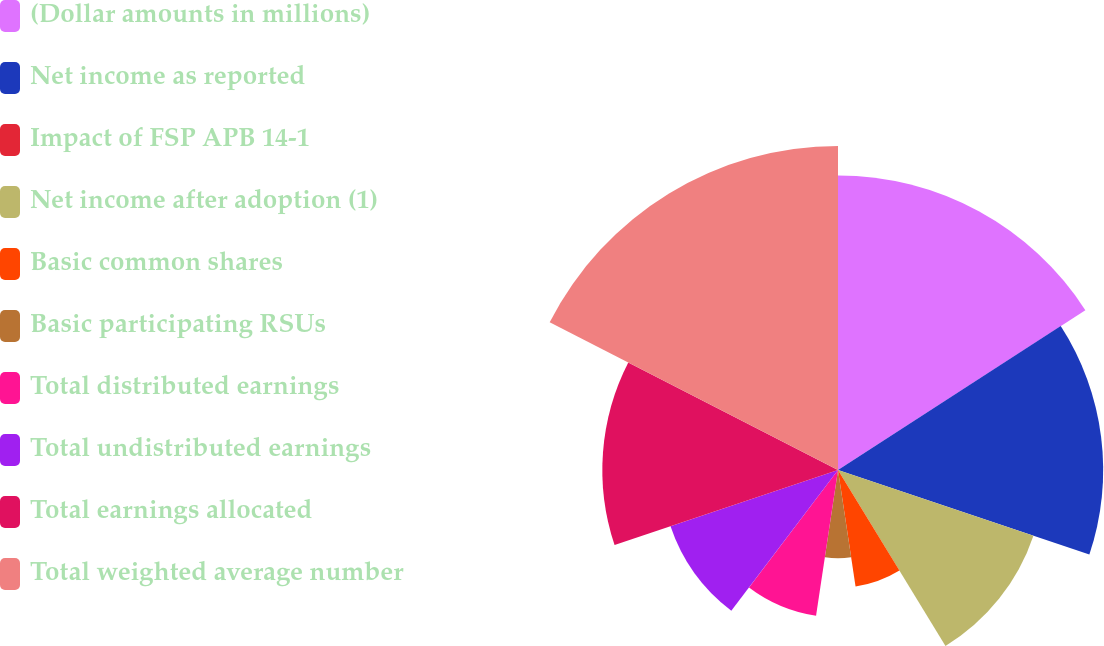<chart> <loc_0><loc_0><loc_500><loc_500><pie_chart><fcel>(Dollar amounts in millions)<fcel>Net income as reported<fcel>Impact of FSP APB 14-1<fcel>Net income after adoption (1)<fcel>Basic common shares<fcel>Basic participating RSUs<fcel>Total distributed earnings<fcel>Total undistributed earnings<fcel>Total earnings allocated<fcel>Total weighted average number<nl><fcel>15.87%<fcel>14.29%<fcel>0.0%<fcel>11.11%<fcel>6.35%<fcel>4.76%<fcel>7.94%<fcel>9.52%<fcel>12.7%<fcel>17.46%<nl></chart> 